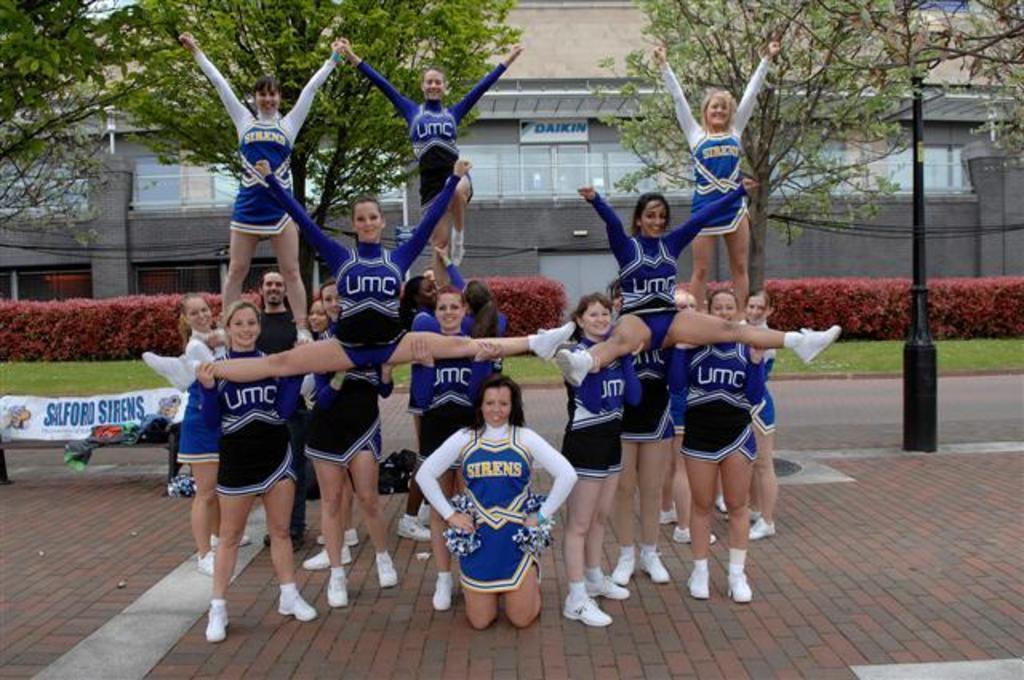Describe this image in one or two sentences. In this image, there is a floor, at the middle there are some people standing, in the background there are some trees, there is a wall, at the right side there is a black color pole. 